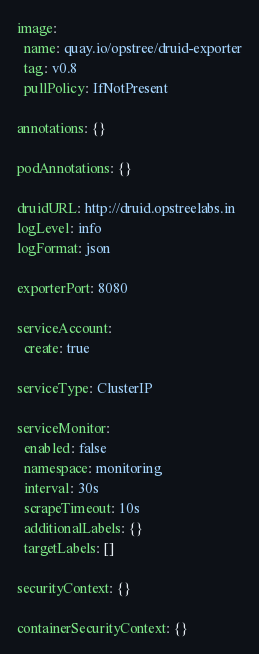<code> <loc_0><loc_0><loc_500><loc_500><_YAML_>
image:
  name: quay.io/opstree/druid-exporter
  tag: v0.8
  pullPolicy: IfNotPresent

annotations: {}

podAnnotations: {}

druidURL: http://druid.opstreelabs.in
logLevel: info
logFormat: json

exporterPort: 8080

serviceAccount:
  create: true

serviceType: ClusterIP

serviceMonitor:
  enabled: false
  namespace: monitoring
  interval: 30s
  scrapeTimeout: 10s
  additionalLabels: {}
  targetLabels: []

securityContext: {}

containerSecurityContext: {}
</code> 